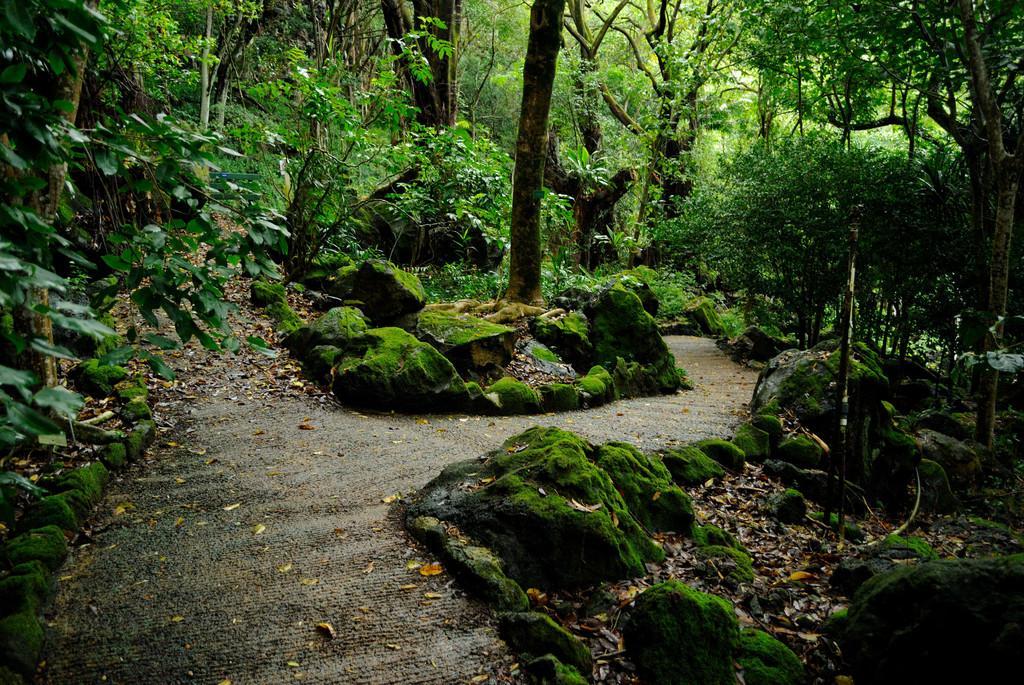Could you give a brief overview of what you see in this image? In this image I can see rocks. There are trees, plants and there are dried leaves on the ground. 